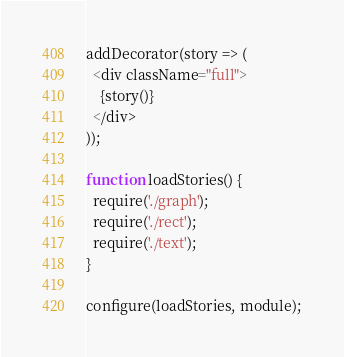Convert code to text. <code><loc_0><loc_0><loc_500><loc_500><_JavaScript_>addDecorator(story => (
  <div className="full">
    {story()}
  </div>
));

function loadStories() {
  require('./graph');
  require('./rect');
  require('./text');
}

configure(loadStories, module);
</code> 